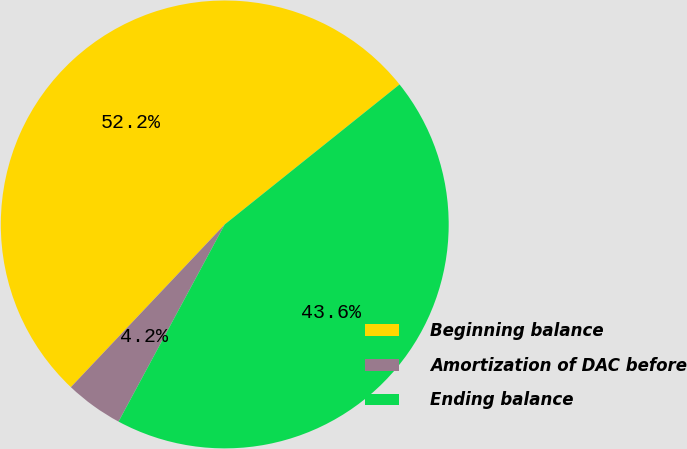<chart> <loc_0><loc_0><loc_500><loc_500><pie_chart><fcel>Beginning balance<fcel>Amortization of DAC before<fcel>Ending balance<nl><fcel>52.2%<fcel>4.19%<fcel>43.61%<nl></chart> 